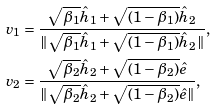<formula> <loc_0><loc_0><loc_500><loc_500>v _ { 1 } & = \frac { \sqrt { \beta _ { 1 } } \hat { h } _ { 1 } + \sqrt { ( 1 - \beta _ { 1 } ) } \hat { h } _ { 2 } } { \| \sqrt { \beta _ { 1 } } \hat { h } _ { 1 } + \sqrt { ( 1 - \beta _ { 1 } ) } \hat { h } _ { 2 } \| } , \\ v _ { 2 } & = \frac { \sqrt { \beta _ { 2 } } \hat { h } _ { 2 } + \sqrt { ( 1 - \beta _ { 2 } ) } \hat { e } } { \| \sqrt { \beta _ { 2 } } \hat { h } _ { 2 } + \sqrt { ( 1 - \beta _ { 2 } ) } \hat { e } \| } ,</formula> 